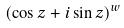<formula> <loc_0><loc_0><loc_500><loc_500>( \cos z + i \sin z ) ^ { w }</formula> 